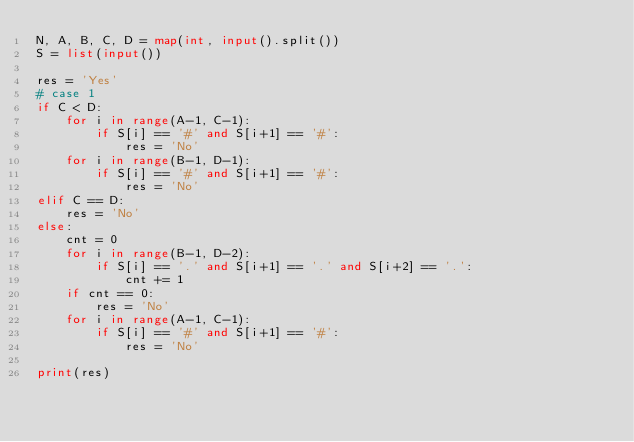Convert code to text. <code><loc_0><loc_0><loc_500><loc_500><_Python_>N, A, B, C, D = map(int, input().split())
S = list(input())

res = 'Yes'
# case 1
if C < D:
    for i in range(A-1, C-1):
        if S[i] == '#' and S[i+1] == '#':
            res = 'No'
    for i in range(B-1, D-1):
        if S[i] == '#' and S[i+1] == '#':
            res = 'No'
elif C == D:
    res = 'No'
else:
    cnt = 0
    for i in range(B-1, D-2):
        if S[i] == '.' and S[i+1] == '.' and S[i+2] == '.':
            cnt += 1
    if cnt == 0:
        res = 'No'
    for i in range(A-1, C-1):
        if S[i] == '#' and S[i+1] == '#':
            res = 'No'

print(res)
</code> 